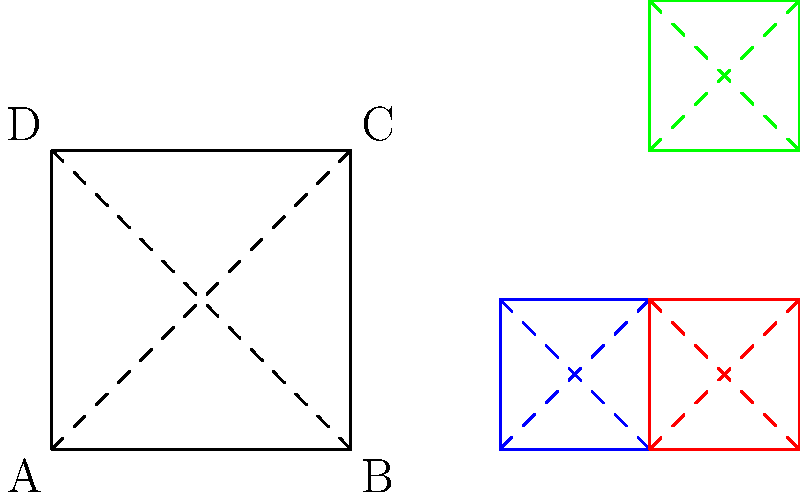While planning a road trip using a GPS app, you encounter a problem involving symmetries of a square. The app's route optimization algorithm uses group theory concepts. If you apply a 90° clockwise rotation (R) followed by a reflection across the vertical axis (V) to a square, what single transformation would produce the same result? Let's approach this step-by-step:

1) First, let's understand what each transformation does:
   - R: 90° clockwise rotation
   - V: Reflection across the vertical axis

2) We need to compose these transformations: V ∘ R (read as "V after R")

3) Let's track what happens to a point, say the top-right corner (C):
   - After R: C moves to the bottom-right corner
   - After V (applied to the result of R): The point moves to the bottom-left corner

4) Now, what single transformation would move C directly to the bottom-left corner?
   - It's a reflection across the diagonal from top-left to bottom-right

5) In group theory terms, we've found that V ∘ R = D, where D is the diagonal reflection

6) This is a key concept in the dihedral group D4, which describes the symmetries of a square

7) Understanding this can help in optimizing routes on a map, as rotations and reflections are often used in navigation algorithms
Answer: Reflection across the diagonal from top-left to bottom-right 